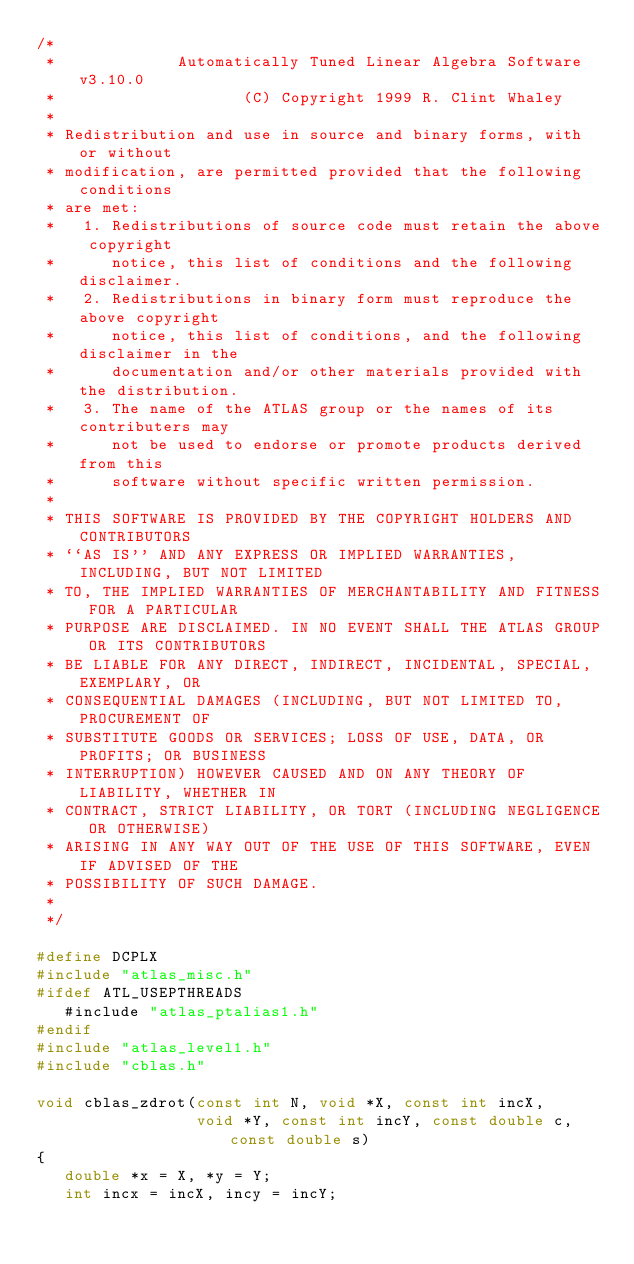Convert code to text. <code><loc_0><loc_0><loc_500><loc_500><_C_>/*
 *             Automatically Tuned Linear Algebra Software v3.10.0
 *                    (C) Copyright 1999 R. Clint Whaley
 *
 * Redistribution and use in source and binary forms, with or without
 * modification, are permitted provided that the following conditions
 * are met:
 *   1. Redistributions of source code must retain the above copyright
 *      notice, this list of conditions and the following disclaimer.
 *   2. Redistributions in binary form must reproduce the above copyright
 *      notice, this list of conditions, and the following disclaimer in the
 *      documentation and/or other materials provided with the distribution.
 *   3. The name of the ATLAS group or the names of its contributers may
 *      not be used to endorse or promote products derived from this
 *      software without specific written permission.
 *
 * THIS SOFTWARE IS PROVIDED BY THE COPYRIGHT HOLDERS AND CONTRIBUTORS
 * ``AS IS'' AND ANY EXPRESS OR IMPLIED WARRANTIES, INCLUDING, BUT NOT LIMITED
 * TO, THE IMPLIED WARRANTIES OF MERCHANTABILITY AND FITNESS FOR A PARTICULAR
 * PURPOSE ARE DISCLAIMED. IN NO EVENT SHALL THE ATLAS GROUP OR ITS CONTRIBUTORS
 * BE LIABLE FOR ANY DIRECT, INDIRECT, INCIDENTAL, SPECIAL, EXEMPLARY, OR
 * CONSEQUENTIAL DAMAGES (INCLUDING, BUT NOT LIMITED TO, PROCUREMENT OF
 * SUBSTITUTE GOODS OR SERVICES; LOSS OF USE, DATA, OR PROFITS; OR BUSINESS
 * INTERRUPTION) HOWEVER CAUSED AND ON ANY THEORY OF LIABILITY, WHETHER IN
 * CONTRACT, STRICT LIABILITY, OR TORT (INCLUDING NEGLIGENCE OR OTHERWISE)
 * ARISING IN ANY WAY OUT OF THE USE OF THIS SOFTWARE, EVEN IF ADVISED OF THE
 * POSSIBILITY OF SUCH DAMAGE.
 *
 */

#define DCPLX
#include "atlas_misc.h"
#ifdef ATL_USEPTHREADS
   #include "atlas_ptalias1.h"
#endif
#include "atlas_level1.h"
#include "cblas.h"

void cblas_zdrot(const int N, void *X, const int incX,
                 void *Y, const int incY, const double c, const double s)
{
   double *x = X, *y = Y;
   int incx = incX, incy = incY;
</code> 